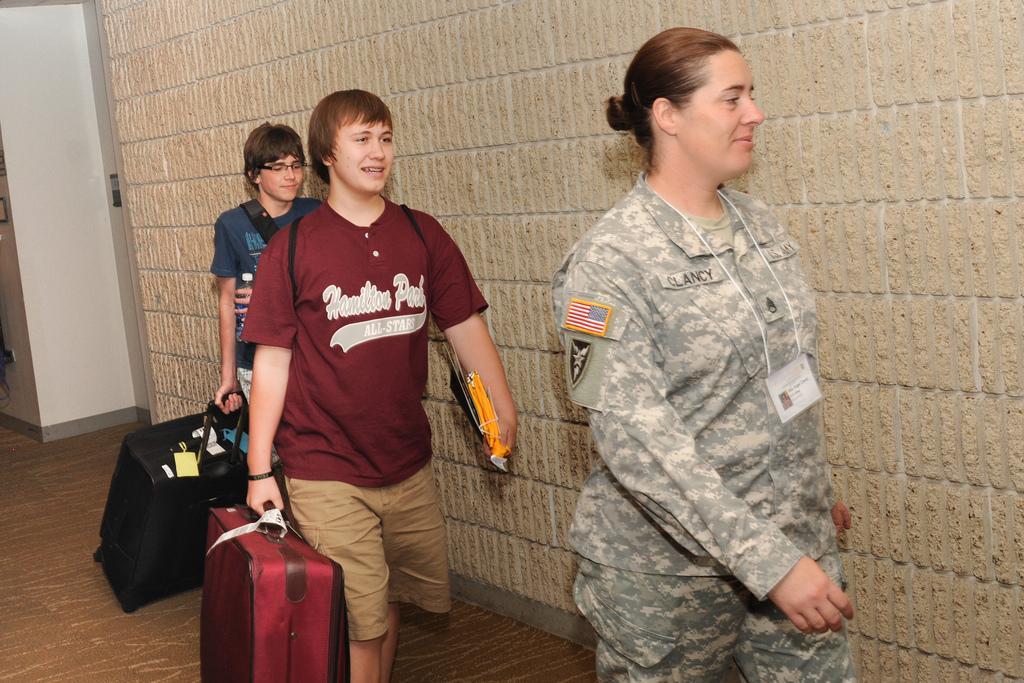Describe this image in one or two sentences. In this image there are three persons who are walking and they are holding luggages and bags, and on the top there is a wall and on the left side there is a wall. 